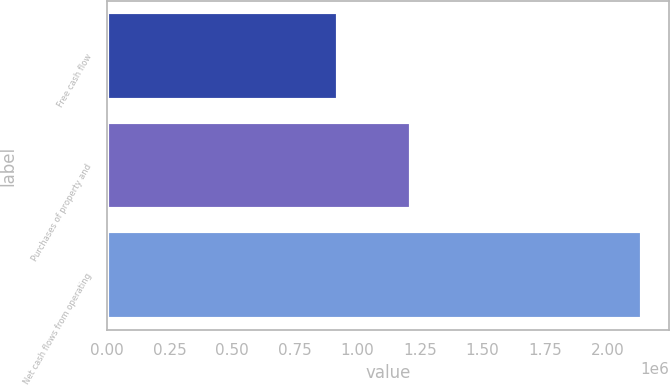<chart> <loc_0><loc_0><loc_500><loc_500><bar_chart><fcel>Free cash flow<fcel>Purchases of property and<fcel>Net cash flows from operating<nl><fcel>923670<fcel>1.21613e+06<fcel>2.1398e+06<nl></chart> 